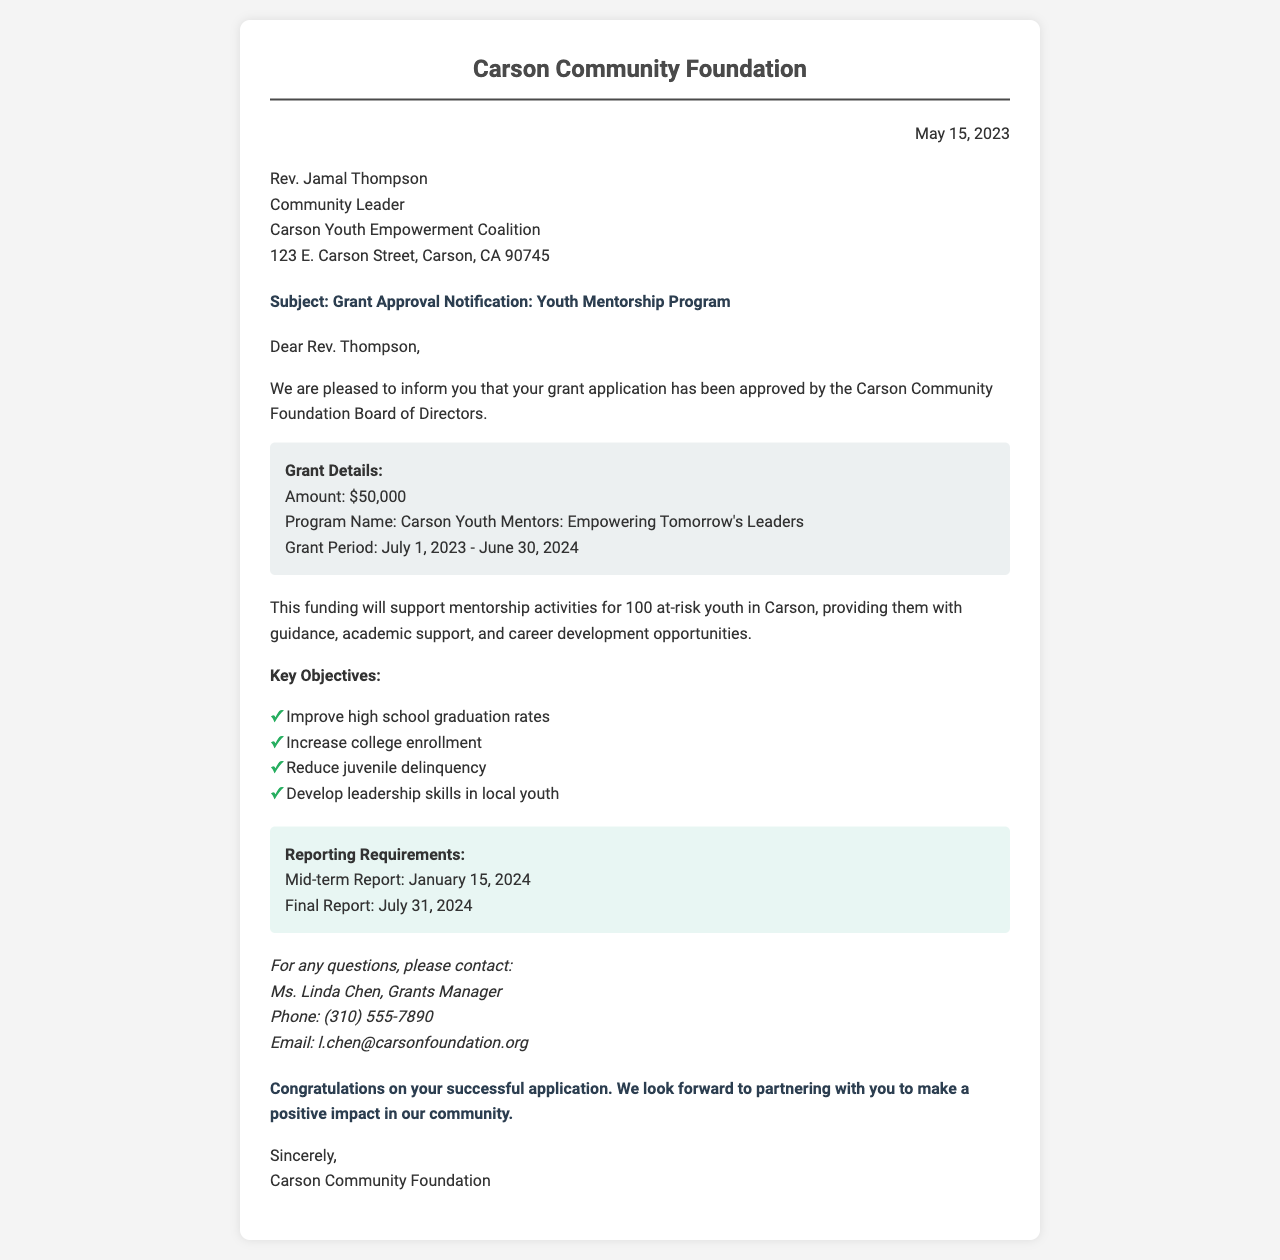what is the name of the program? The program name is explicitly stated in the grant details section of the document.
Answer: Carson Youth Mentors: Empowering Tomorrow's Leaders what is the grant amount? The grant amount is specified in the grant details section of the document.
Answer: $50,000 what are the reporting deadlines? The reporting requirements section lists the mid-term and final report due dates.
Answer: January 15, 2024, and July 31, 2024 who is the grants manager? The contact information section provides details about the grants manager.
Answer: Ms. Linda Chen what is the purpose of the funding? The document describes the purpose of the funding in the context of supporting at-risk youth.
Answer: Support mentorship activities for 100 at-risk youth in Carson how long is the grant period? The grant period is described in the grant details section, providing a start and end date.
Answer: July 1, 2023 - June 30, 2024 what are the key objectives of the program? The key objectives section lists aspirations tied to the mentorship program's success.
Answer: Improve high school graduation rates, Increase college enrollment, Reduce juvenile delinquency, Develop leadership skills in local youth when was the grant application approved? The approval notification date is mentioned at the beginning of the document.
Answer: May 15, 2023 what is the name of the community leader addressed in the letter? The recipient section provides the name of the community leader addressed.
Answer: Rev. Jamal Thompson 